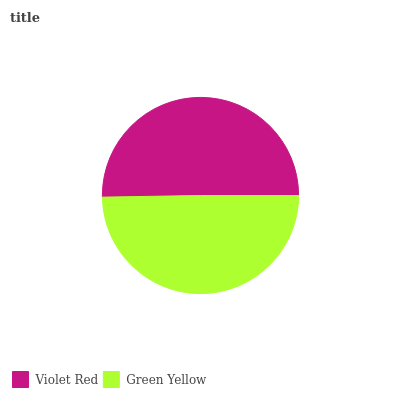Is Green Yellow the minimum?
Answer yes or no. Yes. Is Violet Red the maximum?
Answer yes or no. Yes. Is Green Yellow the maximum?
Answer yes or no. No. Is Violet Red greater than Green Yellow?
Answer yes or no. Yes. Is Green Yellow less than Violet Red?
Answer yes or no. Yes. Is Green Yellow greater than Violet Red?
Answer yes or no. No. Is Violet Red less than Green Yellow?
Answer yes or no. No. Is Violet Red the high median?
Answer yes or no. Yes. Is Green Yellow the low median?
Answer yes or no. Yes. Is Green Yellow the high median?
Answer yes or no. No. Is Violet Red the low median?
Answer yes or no. No. 